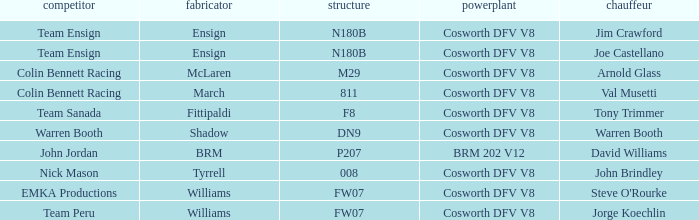What team used the BRM built car? John Jordan. 